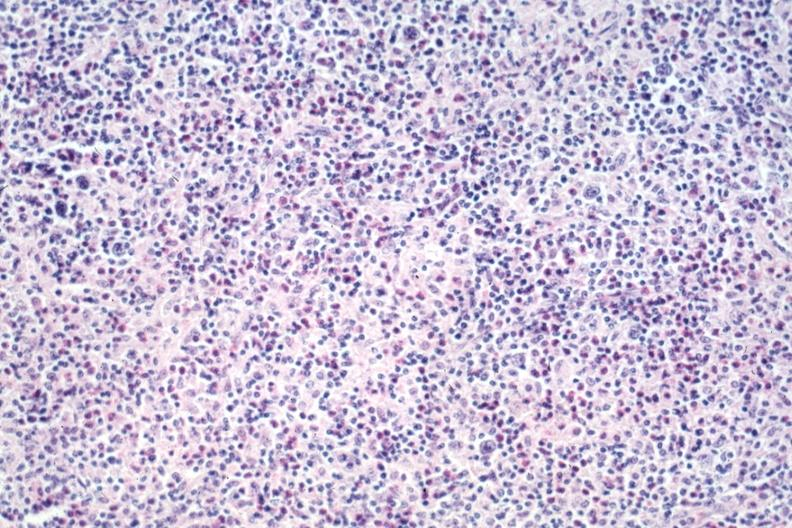what is present?
Answer the question using a single word or phrase. Lymph node 